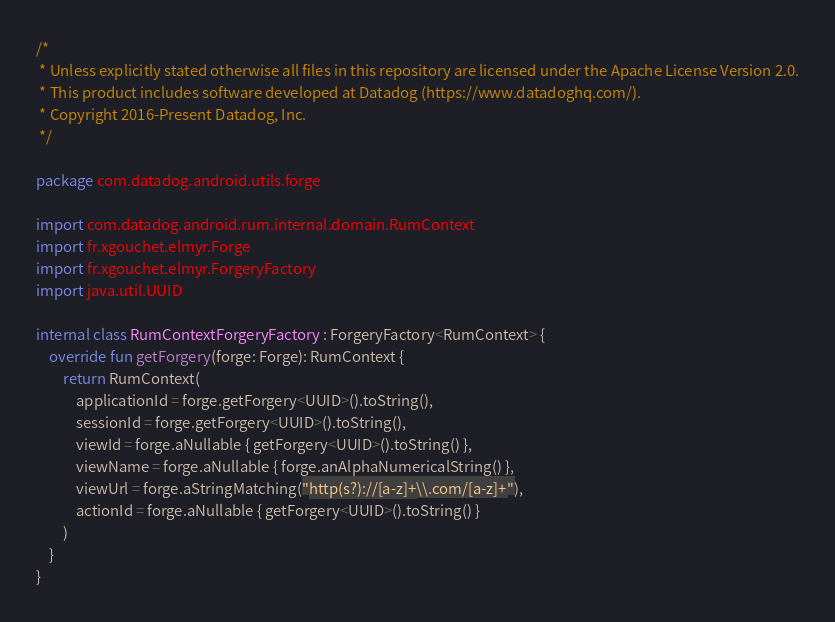<code> <loc_0><loc_0><loc_500><loc_500><_Kotlin_>/*
 * Unless explicitly stated otherwise all files in this repository are licensed under the Apache License Version 2.0.
 * This product includes software developed at Datadog (https://www.datadoghq.com/).
 * Copyright 2016-Present Datadog, Inc.
 */

package com.datadog.android.utils.forge

import com.datadog.android.rum.internal.domain.RumContext
import fr.xgouchet.elmyr.Forge
import fr.xgouchet.elmyr.ForgeryFactory
import java.util.UUID

internal class RumContextForgeryFactory : ForgeryFactory<RumContext> {
    override fun getForgery(forge: Forge): RumContext {
        return RumContext(
            applicationId = forge.getForgery<UUID>().toString(),
            sessionId = forge.getForgery<UUID>().toString(),
            viewId = forge.aNullable { getForgery<UUID>().toString() },
            viewName = forge.aNullable { forge.anAlphaNumericalString() },
            viewUrl = forge.aStringMatching("http(s?)://[a-z]+\\.com/[a-z]+"),
            actionId = forge.aNullable { getForgery<UUID>().toString() }
        )
    }
}
</code> 